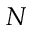<formula> <loc_0><loc_0><loc_500><loc_500>N</formula> 